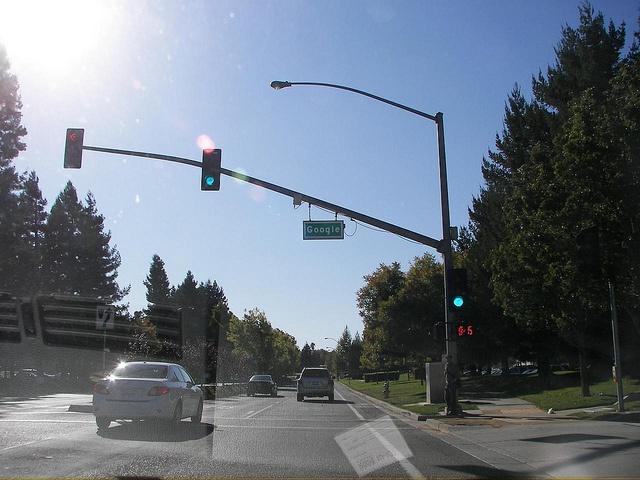Describe the objects in this image and their specific colors. I can see car in white, gray, darkgray, and lightgray tones, car in white, black, and gray tones, traffic light in white, black, cyan, and blue tones, people in white, black, and gray tones, and traffic light in white, gray, purple, and brown tones in this image. 